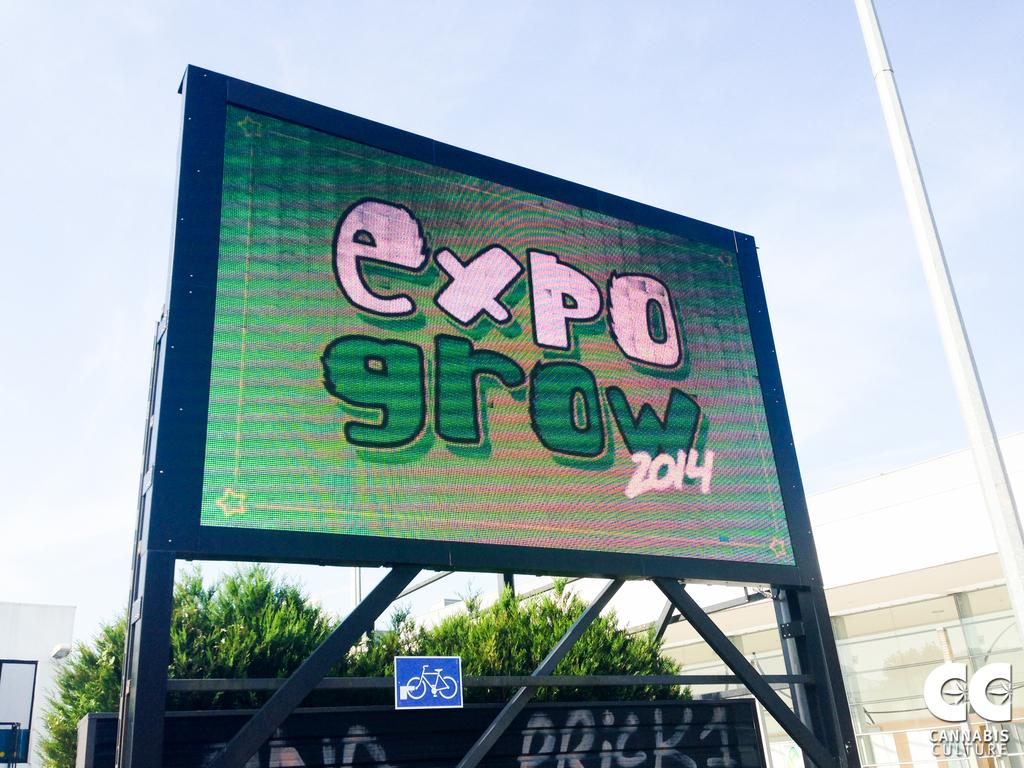<image>
Provide a brief description of the given image. An electronic board is outdoors, the board reads "expo growth" in pink and green letters. 